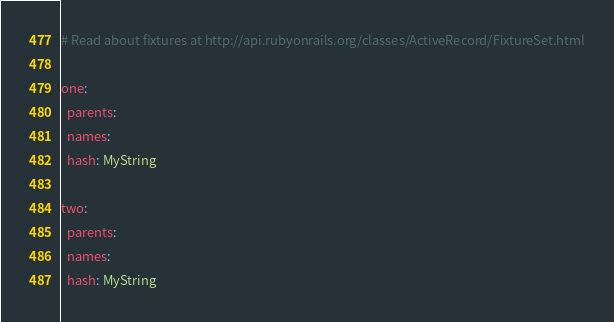Convert code to text. <code><loc_0><loc_0><loc_500><loc_500><_YAML_># Read about fixtures at http://api.rubyonrails.org/classes/ActiveRecord/FixtureSet.html

one:
  parents: 
  names: 
  hash: MyString

two:
  parents: 
  names: 
  hash: MyString
</code> 